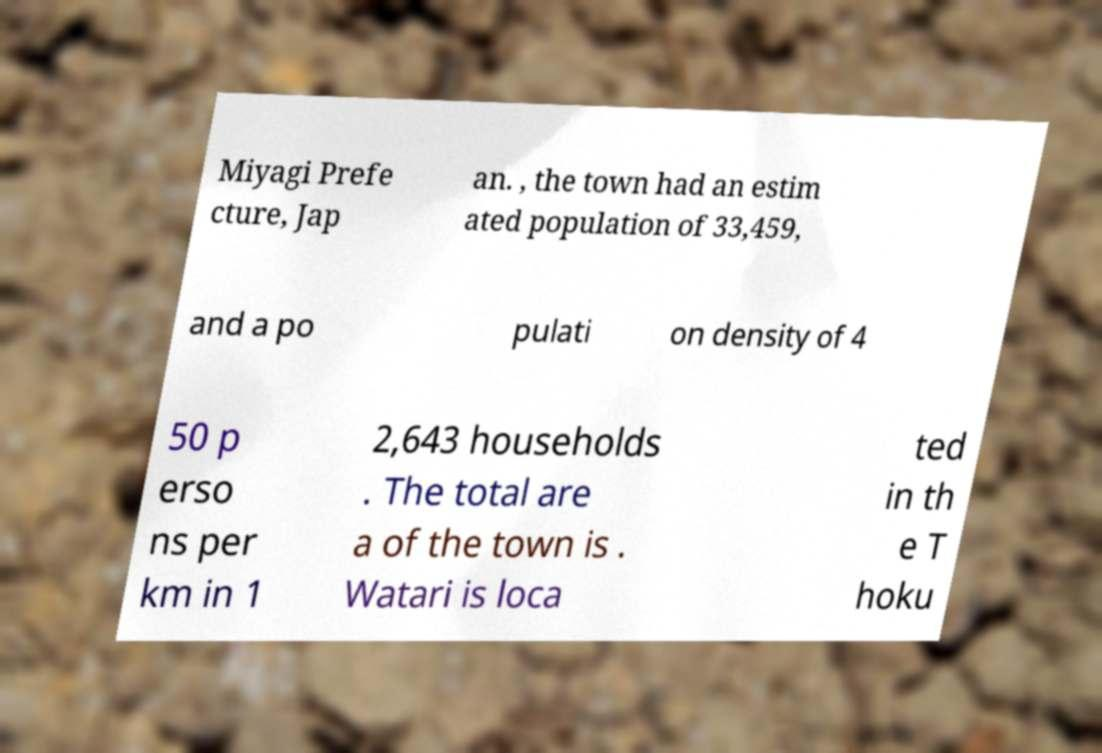For documentation purposes, I need the text within this image transcribed. Could you provide that? Miyagi Prefe cture, Jap an. , the town had an estim ated population of 33,459, and a po pulati on density of 4 50 p erso ns per km in 1 2,643 households . The total are a of the town is . Watari is loca ted in th e T hoku 